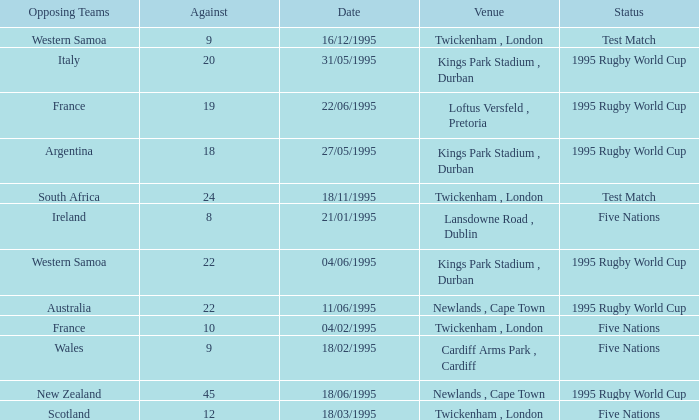What date has a status of 1995 rugby world cup and an against of 20? 31/05/1995. 